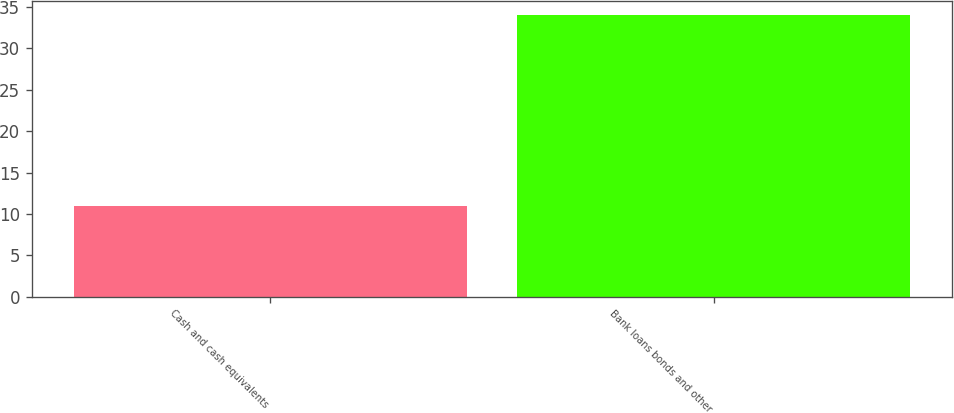<chart> <loc_0><loc_0><loc_500><loc_500><bar_chart><fcel>Cash and cash equivalents<fcel>Bank loans bonds and other<nl><fcel>11<fcel>34<nl></chart> 